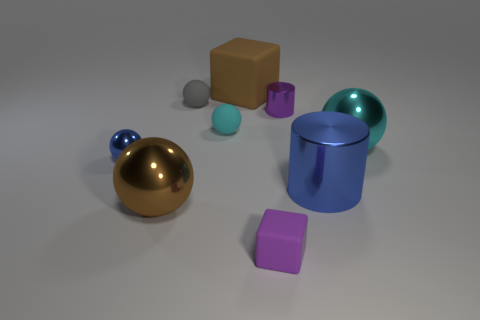What material is the sphere that is the same color as the big cylinder?
Give a very brief answer. Metal. Are there any other things that have the same shape as the small cyan object?
Provide a short and direct response. Yes. There is a big blue metal thing; is it the same shape as the shiny object that is behind the big cyan metallic thing?
Your response must be concise. Yes. How many other things are made of the same material as the large cyan ball?
Your response must be concise. 4. Does the large block have the same color as the large metallic object to the left of the small purple metal cylinder?
Provide a short and direct response. Yes. What material is the brown thing right of the large brown metal sphere?
Ensure brevity in your answer.  Rubber. Are there any tiny rubber things of the same color as the tiny metallic cylinder?
Give a very brief answer. Yes. What is the color of the matte sphere that is the same size as the gray matte thing?
Your response must be concise. Cyan. How many tiny things are either brown metallic spheres or purple shiny balls?
Make the answer very short. 0. Are there an equal number of purple matte cubes behind the big brown rubber block and gray things in front of the small blue metallic ball?
Your answer should be very brief. Yes. 